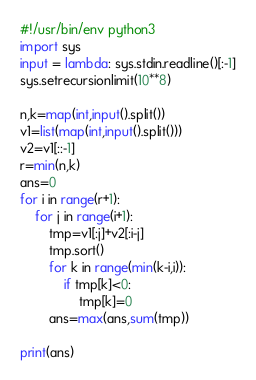<code> <loc_0><loc_0><loc_500><loc_500><_Python_>#!/usr/bin/env python3
import sys
input = lambda: sys.stdin.readline()[:-1]
sys.setrecursionlimit(10**8)

n,k=map(int,input().split())
v1=list(map(int,input().split()))
v2=v1[::-1]
r=min(n,k)
ans=0
for i in range(r+1):
    for j in range(i+1):
        tmp=v1[:j]+v2[:i-j]
        tmp.sort()
        for k in range(min(k-i,i)):
            if tmp[k]<0:
                tmp[k]=0
        ans=max(ans,sum(tmp))

print(ans)</code> 